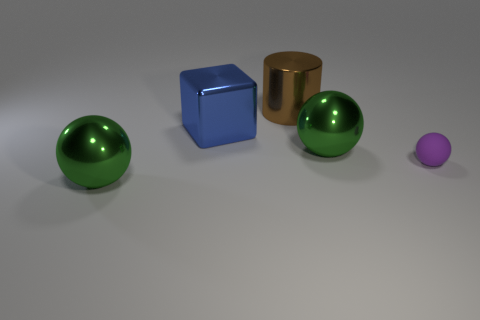Is there anything else that is the same material as the purple object?
Provide a short and direct response. No. Is there a big metallic object of the same shape as the matte object?
Give a very brief answer. Yes. What number of objects are either objects that are behind the tiny purple matte thing or large brown cylinders?
Ensure brevity in your answer.  3. There is a shiny sphere that is behind the rubber sphere; is it the same color as the big ball that is on the left side of the big brown metallic cylinder?
Provide a succinct answer. Yes. How big is the purple sphere?
Ensure brevity in your answer.  Small. How many large things are either green spheres or brown shiny cylinders?
Provide a succinct answer. 3. What is the color of the cube that is the same size as the shiny cylinder?
Provide a succinct answer. Blue. What number of other objects are the same shape as the blue object?
Make the answer very short. 0. Are there any blue objects that have the same material as the big brown thing?
Keep it short and to the point. Yes. Is the material of the large ball that is behind the purple rubber object the same as the purple object that is right of the cylinder?
Keep it short and to the point. No. 